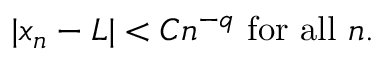<formula> <loc_0><loc_0><loc_500><loc_500>| x _ { n } - L | < C n ^ { - q } { f o r a l l } n .</formula> 